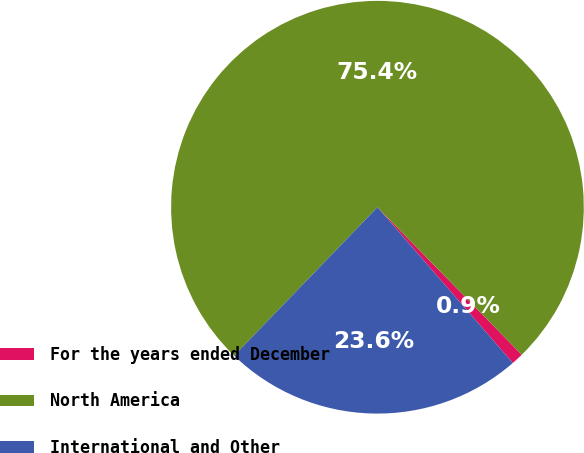Convert chart. <chart><loc_0><loc_0><loc_500><loc_500><pie_chart><fcel>For the years ended December<fcel>North America<fcel>International and Other<nl><fcel>0.94%<fcel>75.45%<fcel>23.61%<nl></chart> 